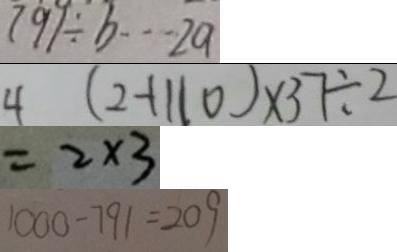<formula> <loc_0><loc_0><loc_500><loc_500>7 9 1 \div b \cdots 2 a 
 4 ( 2 + 1 1 0 ) \times 3 7 \div 2 
 = 2 \times 3 
 1 0 0 0 - 7 9 1 = 2 0 9</formula> 